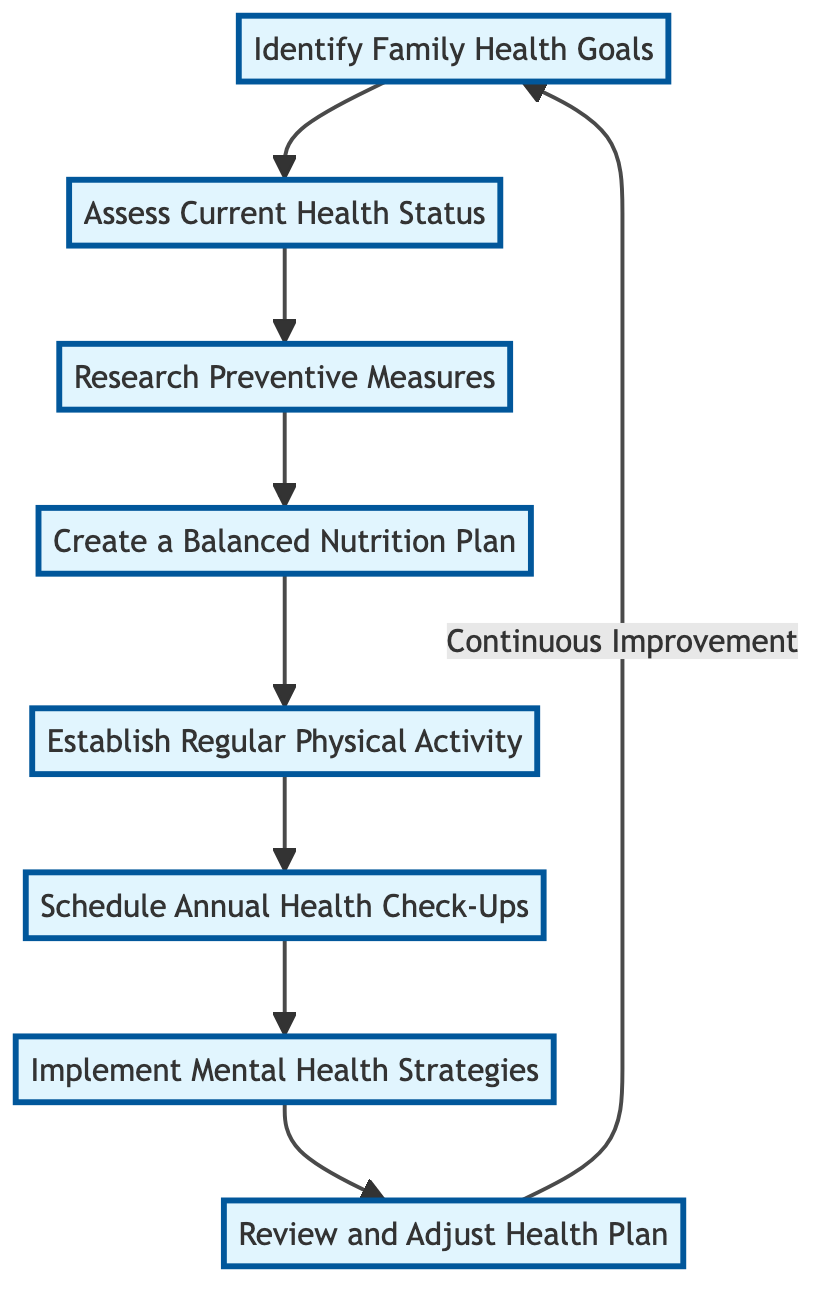What is the first step in the health plan? The diagram indicates that the first step is "Identify Family Health Goals," which starts the flow of the plan.
Answer: Identify Family Health Goals How many steps are in the health plan? By counting the nodes in the diagram, including the loop back to the beginning, there are a total of 8 steps.
Answer: 8 What step comes after "Assess Current Health Status"? From the diagram, it shows that the step directly following "Assess Current Health Status" is "Research Preventive Measures."
Answer: Research Preventive Measures Which step focuses on nutrition? The diagram shows "Create a Balanced Nutrition Plan" as the step specifically aimed at nutrition within the health plan.
Answer: Create a Balanced Nutrition Plan What happens after "Schedule Annual Health Check-Ups"? The flowchart indicates that following "Schedule Annual Health Check-Ups," the next step is "Implement Mental Health Strategies."
Answer: Implement Mental Health Strategies How does the flowchart encourage continuous improvement? The diagram illustrates a feedback loop where the last step, "Review and Adjust Health Plan," leads back to the first step, denoting a continuous cycle of improvement.
Answer: Continuous Improvement What is the purpose of "Implement Mental Health Strategies"? The diagram highlights that this step is aimed at incorporating activities that promote mental wellness in the family's health plan.
Answer: Promote mental wellness What does the arrow from "Review and Adjust Health Plan" signify? The arrow indicates a loop that connects back to "Identify Family Health Goals," showing that the plan is meant to be revisited and revised constantly.
Answer: Continuous feedback loop What type of activities are suggested in the "Implement Mental Health Strategies" step? This step incorporates activities like family discussions and mindfulness exercises, promoting overall mental health in the family.
Answer: Family discussions and mindfulness exercises 